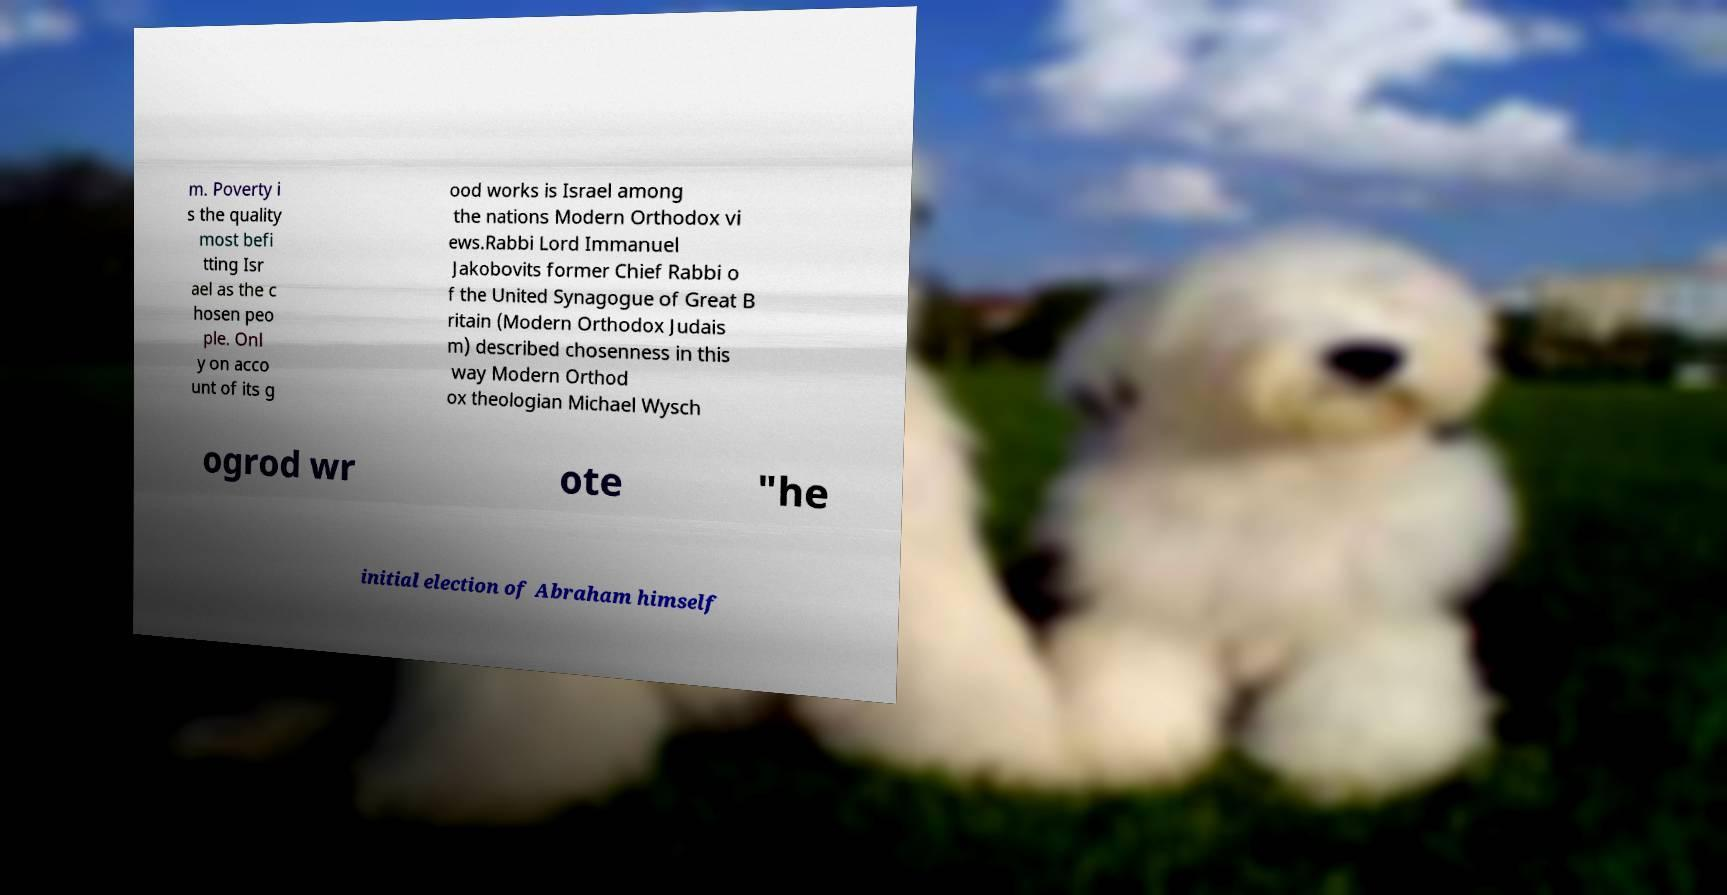Could you extract and type out the text from this image? m. Poverty i s the quality most befi tting Isr ael as the c hosen peo ple. Onl y on acco unt of its g ood works is Israel among the nations Modern Orthodox vi ews.Rabbi Lord Immanuel Jakobovits former Chief Rabbi o f the United Synagogue of Great B ritain (Modern Orthodox Judais m) described chosenness in this way Modern Orthod ox theologian Michael Wysch ogrod wr ote "he initial election of Abraham himself 